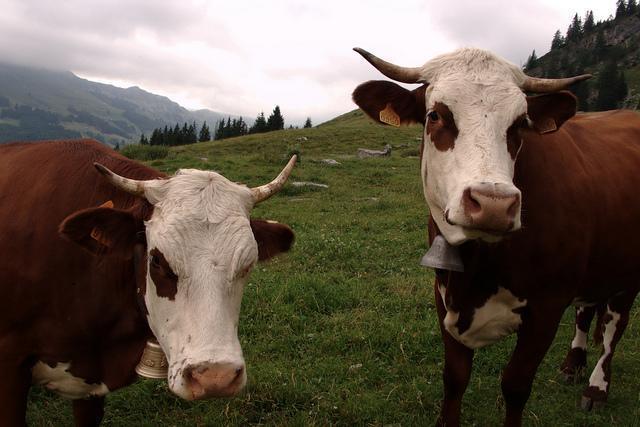How many cows are there?
Give a very brief answer. 2. 